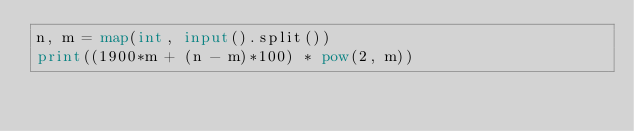<code> <loc_0><loc_0><loc_500><loc_500><_Python_>n, m = map(int, input().split())
print((1900*m + (n - m)*100) * pow(2, m))</code> 